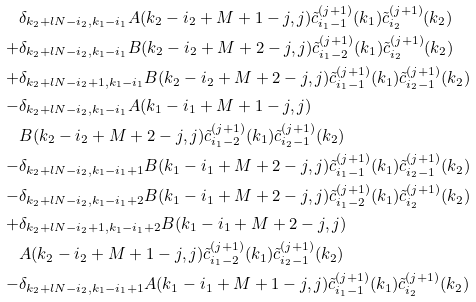<formula> <loc_0><loc_0><loc_500><loc_500>& \delta _ { k _ { 2 } + l N - i _ { 2 } , k _ { 1 } - i _ { 1 } } A ( k _ { 2 } - i _ { 2 } + M + 1 - j , j ) \tilde { c } _ { i _ { 1 } - 1 } ^ { ( j + 1 ) } ( k _ { 1 } ) \tilde { c } _ { i _ { 2 } } ^ { ( j + 1 ) } ( k _ { 2 } ) \\ + & \delta _ { k _ { 2 } + l N - i _ { 2 } , k _ { 1 } - i _ { 1 } } B ( k _ { 2 } - i _ { 2 } + M + 2 - j , j ) \tilde { c } _ { i _ { 1 } - 2 } ^ { ( j + 1 ) } ( k _ { 1 } ) \tilde { c } _ { i _ { 2 } } ^ { ( j + 1 ) } ( k _ { 2 } ) \\ + & \delta _ { k _ { 2 } + l N - i _ { 2 } + 1 , k _ { 1 } - i _ { 1 } } B ( k _ { 2 } - i _ { 2 } + M + 2 - j , j ) \tilde { c } _ { i _ { 1 } - 1 } ^ { ( j + 1 ) } ( k _ { 1 } ) \tilde { c } _ { i _ { 2 } - 1 } ^ { ( j + 1 ) } ( k _ { 2 } ) \\ - & \delta _ { k _ { 2 } + l N - i _ { 2 } , k _ { 1 } - i _ { 1 } } A ( k _ { 1 } - i _ { 1 } + M + 1 - j , j ) \\ & B ( k _ { 2 } - i _ { 2 } + M + 2 - j , j ) \tilde { c } _ { i _ { 1 } - 2 } ^ { ( j + 1 ) } ( k _ { 1 } ) \tilde { c } _ { i _ { 2 } - 1 } ^ { ( j + 1 ) } ( k _ { 2 } ) \\ - & \delta _ { k _ { 2 } + l N - i _ { 2 } , k _ { 1 } - i _ { 1 } + 1 } B ( k _ { 1 } - i _ { 1 } + M + 2 - j , j ) \tilde { c } _ { i _ { 1 } - 1 } ^ { ( j + 1 ) } ( k _ { 1 } ) \tilde { c } _ { i _ { 2 } - 1 } ^ { ( j + 1 ) } ( k _ { 2 } ) \\ - & \delta _ { k _ { 2 } + l N - i _ { 2 } , k _ { 1 } - i _ { 1 } + 2 } B ( k _ { 1 } - i _ { 1 } + M + 2 - j , j ) \tilde { c } _ { i _ { 1 } - 2 } ^ { ( j + 1 ) } ( k _ { 1 } ) \tilde { c } _ { i _ { 2 } } ^ { ( j + 1 ) } ( k _ { 2 } ) \\ + & \delta _ { k _ { 2 } + l N - i _ { 2 } + 1 , k _ { 1 } - i _ { 1 } + 2 } B ( k _ { 1 } - i _ { 1 } + M + 2 - j , j ) \\ & A ( k _ { 2 } - i _ { 2 } + M + 1 - j , j ) \tilde { c } _ { i _ { 1 } - 2 } ^ { ( j + 1 ) } ( k _ { 1 } ) \tilde { c } _ { i _ { 2 } - 1 } ^ { ( j + 1 ) } ( k _ { 2 } ) \\ - & \delta _ { k _ { 2 } + l N - i _ { 2 } , k _ { 1 } - i _ { 1 } + 1 } A ( k _ { 1 } - i _ { 1 } + M + 1 - j , j ) \tilde { c } _ { i _ { 1 } - 1 } ^ { ( j + 1 ) } ( k _ { 1 } ) \tilde { c } _ { i _ { 2 } } ^ { ( j + 1 ) } ( k _ { 2 } ) \\</formula> 